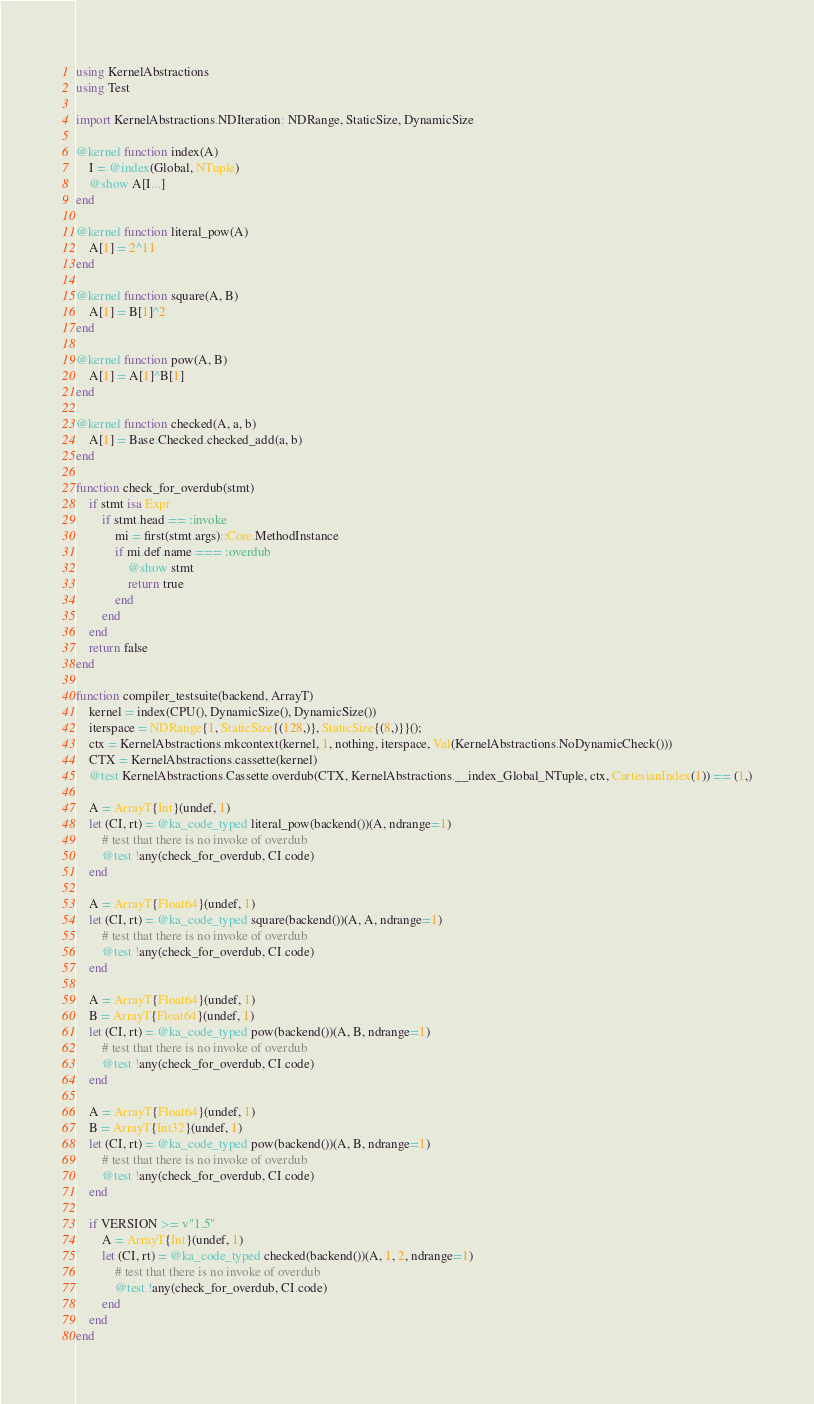<code> <loc_0><loc_0><loc_500><loc_500><_Julia_>using KernelAbstractions
using Test

import KernelAbstractions.NDIteration: NDRange, StaticSize, DynamicSize

@kernel function index(A)
    I = @index(Global, NTuple)
    @show A[I...]
end

@kernel function literal_pow(A)
    A[1] = 2^11
end

@kernel function square(A, B)
    A[1] = B[1]^2
end

@kernel function pow(A, B)
    A[1] = A[1]^B[1]
end

@kernel function checked(A, a, b)
    A[1] = Base.Checked.checked_add(a, b)
end

function check_for_overdub(stmt)
    if stmt isa Expr
        if stmt.head == :invoke
            mi = first(stmt.args)::Core.MethodInstance
            if mi.def.name === :overdub
                @show stmt
                return true
            end
        end
    end
    return false
end

function compiler_testsuite(backend, ArrayT)
    kernel = index(CPU(), DynamicSize(), DynamicSize())
    iterspace = NDRange{1, StaticSize{(128,)}, StaticSize{(8,)}}();
    ctx = KernelAbstractions.mkcontext(kernel, 1, nothing, iterspace, Val(KernelAbstractions.NoDynamicCheck()))
    CTX = KernelAbstractions.cassette(kernel)
    @test KernelAbstractions.Cassette.overdub(CTX, KernelAbstractions.__index_Global_NTuple, ctx, CartesianIndex(1)) == (1,)

    A = ArrayT{Int}(undef, 1)
    let (CI, rt) = @ka_code_typed literal_pow(backend())(A, ndrange=1)
        # test that there is no invoke of overdub
        @test !any(check_for_overdub, CI.code)
    end

    A = ArrayT{Float64}(undef, 1)
    let (CI, rt) = @ka_code_typed square(backend())(A, A, ndrange=1)
        # test that there is no invoke of overdub
        @test !any(check_for_overdub, CI.code)
    end

    A = ArrayT{Float64}(undef, 1)
    B = ArrayT{Float64}(undef, 1)
    let (CI, rt) = @ka_code_typed pow(backend())(A, B, ndrange=1)
        # test that there is no invoke of overdub
        @test !any(check_for_overdub, CI.code)
    end

    A = ArrayT{Float64}(undef, 1)
    B = ArrayT{Int32}(undef, 1)
    let (CI, rt) = @ka_code_typed pow(backend())(A, B, ndrange=1)
        # test that there is no invoke of overdub
        @test !any(check_for_overdub, CI.code)
    end

    if VERSION >= v"1.5"
        A = ArrayT{Int}(undef, 1)
        let (CI, rt) = @ka_code_typed checked(backend())(A, 1, 2, ndrange=1)
            # test that there is no invoke of overdub
            @test !any(check_for_overdub, CI.code)
        end
    end
end
</code> 